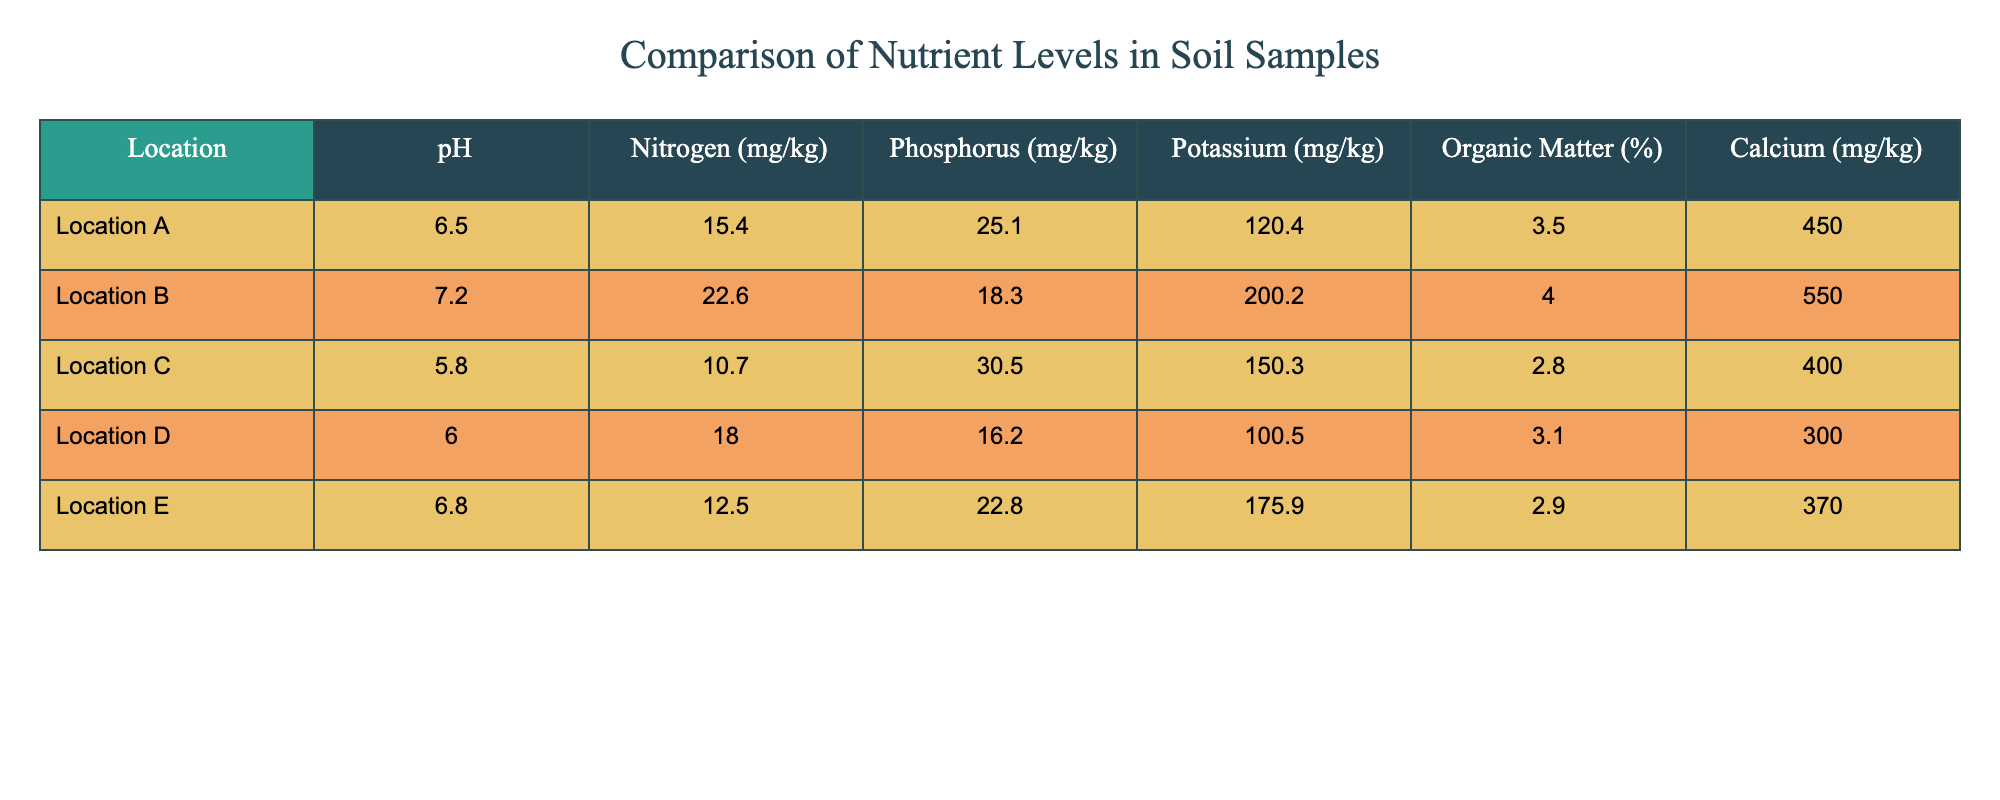What is the pH level of Location B? Referring to the table, the pH level for Location B is directly stated as 7.2.
Answer: 7.2 Which location has the highest Potassium level? By comparing the Potassium levels across the table, Location B has the highest level at 200.2 mg/kg.
Answer: Location B What is the average Nitrogen level of all locations? To find the average, sum the Nitrogen levels: 15.4 + 22.6 + 10.7 + 18.0 + 12.5 = 79.2 mg/kg. There are 5 locations, so the average is 79.2 / 5 = 15.84 mg/kg.
Answer: 15.84 mg/kg Is the Organic Matter percentage of Location C greater than that of Location D? Location C has an Organic Matter percentage of 2.8%, while Location D has 3.1%. Since 2.8% is not greater than 3.1%, the answer is no.
Answer: No What is the difference in Calcium levels between Location B and Location D? The Calcium level in Location B is 550.0 mg/kg and in Location D, it is 300.0 mg/kg. The difference is calculated by subtracting: 550.0 - 300.0 = 250.0 mg/kg.
Answer: 250.0 mg/kg Which location has the lowest Phosphorus level? Observing the Phosphorus levels in the table, Location B has the lowest value at 18.3 mg/kg.
Answer: Location B If we want to know the total Nitrogen level for Location A, C, and E combined, what would it be? The Nitrogen levels for these locations are 15.4 mg/kg (A), 10.7 mg/kg (C), and 12.5 mg/kg (E). Adding these together: 15.4 + 10.7 + 12.5 = 38.6 mg/kg.
Answer: 38.6 mg/kg Does Location E have a higher Phosphorus level than Location D? Location E has a Phosphorus level of 22.8 mg/kg, while Location D has 16.2 mg/kg. Since 22.8 mg/kg is greater than 16.2 mg/kg, the answer is yes.
Answer: Yes What is the average Organic Matter percentage among all locations? To calculate the average, sum the Organic Matter percentages: 3.5 + 4.0 + 2.8 + 3.1 + 2.9 = 16.3%. Dividing by the number of locations (5), the average is 16.3 / 5 = 3.26%.
Answer: 3.26% 